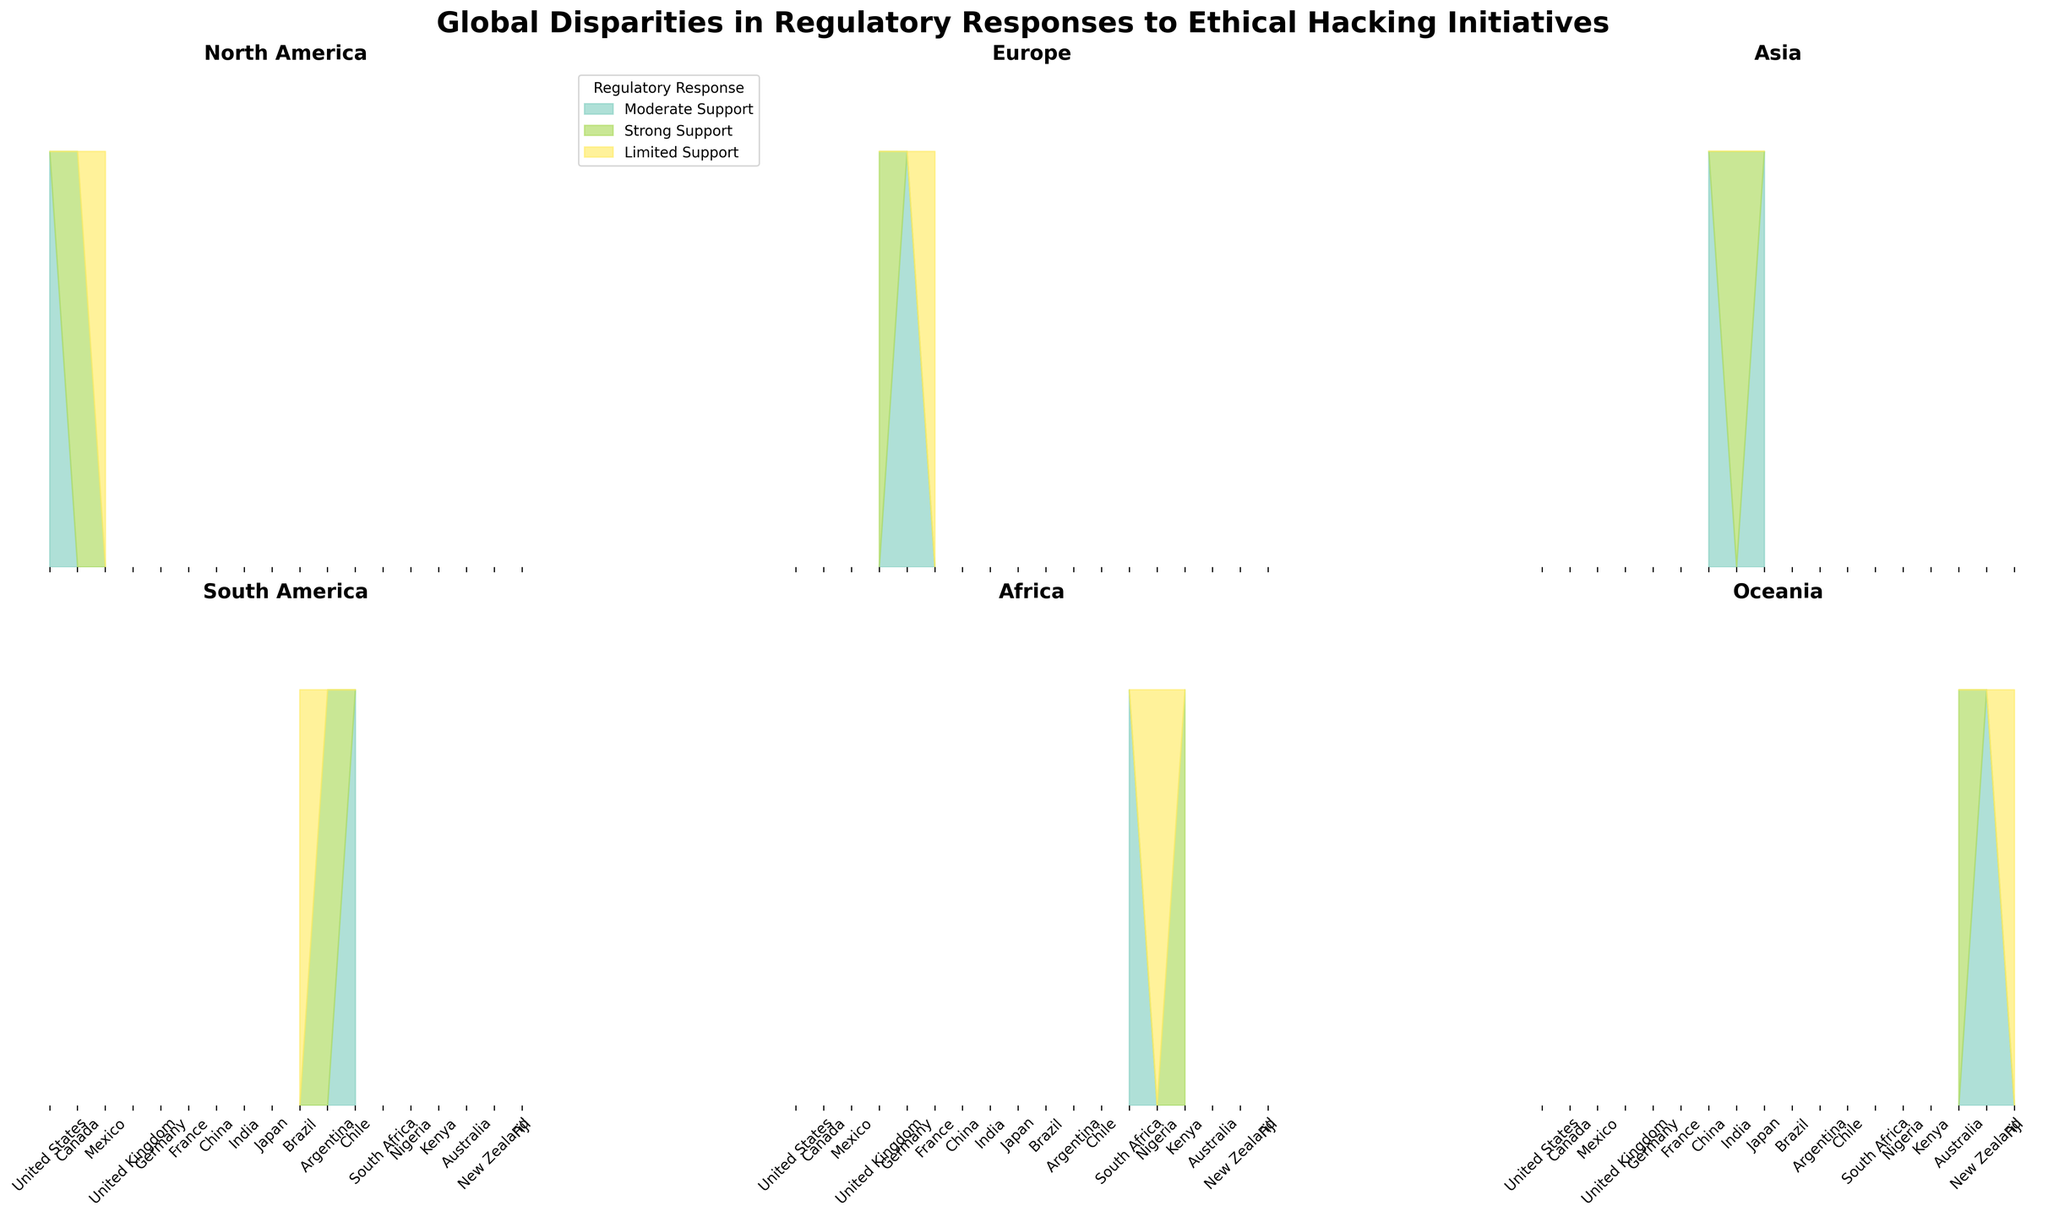How many regions are displayed in the figure? There are 2 rows and 3 columns of subplots. Each subplot represents a unique region, so there are 6 regions in total.
Answer: 6 Which region displays the strongest overall support for ethical hacking initiatives? The region with the most area filled by the color representing "Strong Support" would be displaying the strongest overall support. By comparing the subplots, we observe that Europe and Oceania have the largest proportion of "Strong Support" areas.
Answer: Europe and Oceania What's the title of the figure? The title of the figure is shown at the top in a large, bold font. It reads "Global Disparities in Regulatory Responses to Ethical Hacking Initiatives."
Answer: Global Disparities in Regulatory Responses to Ethical Hacking Initiatives Which country in North America has the least supporting regulatory response? The subplot for North America needs to be examined to identify the country with the smallest area under strong or moderate support colors. This is Mexico, which shows "Limited Support."
Answer: Mexico Are there any regions with no 'No Consequences' regulatory response? By looking across the subplots to identify if there's any region without the area filled for "No Consequences," we see that South America and Africa do not have this response.
Answer: South America and Africa What's the breakdown of regulatory responses in Europe? By examining the European subplot, it appears:
  - Strong Support: United Kingdom
  - Moderate Support: Germany
  - Limited Support: France
Answer: UK: Strong, Germany: Moderate, France: Limited Which region exhibits the most diverse types of legal consequences? The diversity of legal consequences is represented by multiple different legal consequence areas in a single region's subplot. North America has community service, cash rewards, and fines, indicating the most diverse legal consequences.
Answer: North America Between Africa and Asia, which region has more instances of 'Strong Support'? By comparing the subplots of Africa and Asia, count the instances where a country has the "Strong Support" area filled. Africa has 1 (Kenya) while Asia has 2 (India and Japan).
Answer: Asia What is the primary regulatory response in South America? By assessing the relative areas filled in the South America subplot, we find that "Moderate Support" is the dominant response, occupying Brazil and Argentina.
Answer: Moderate Support Which region has the highest proportion of legal consequences involving "No Consequences"? Examine and compare the subplots for "No Consequences" areas. Europe and Oceania each have one country marked with "No Consequences," but Oceania has fewer other legal consequences, making it higher in proportion.
Answer: Oceania 